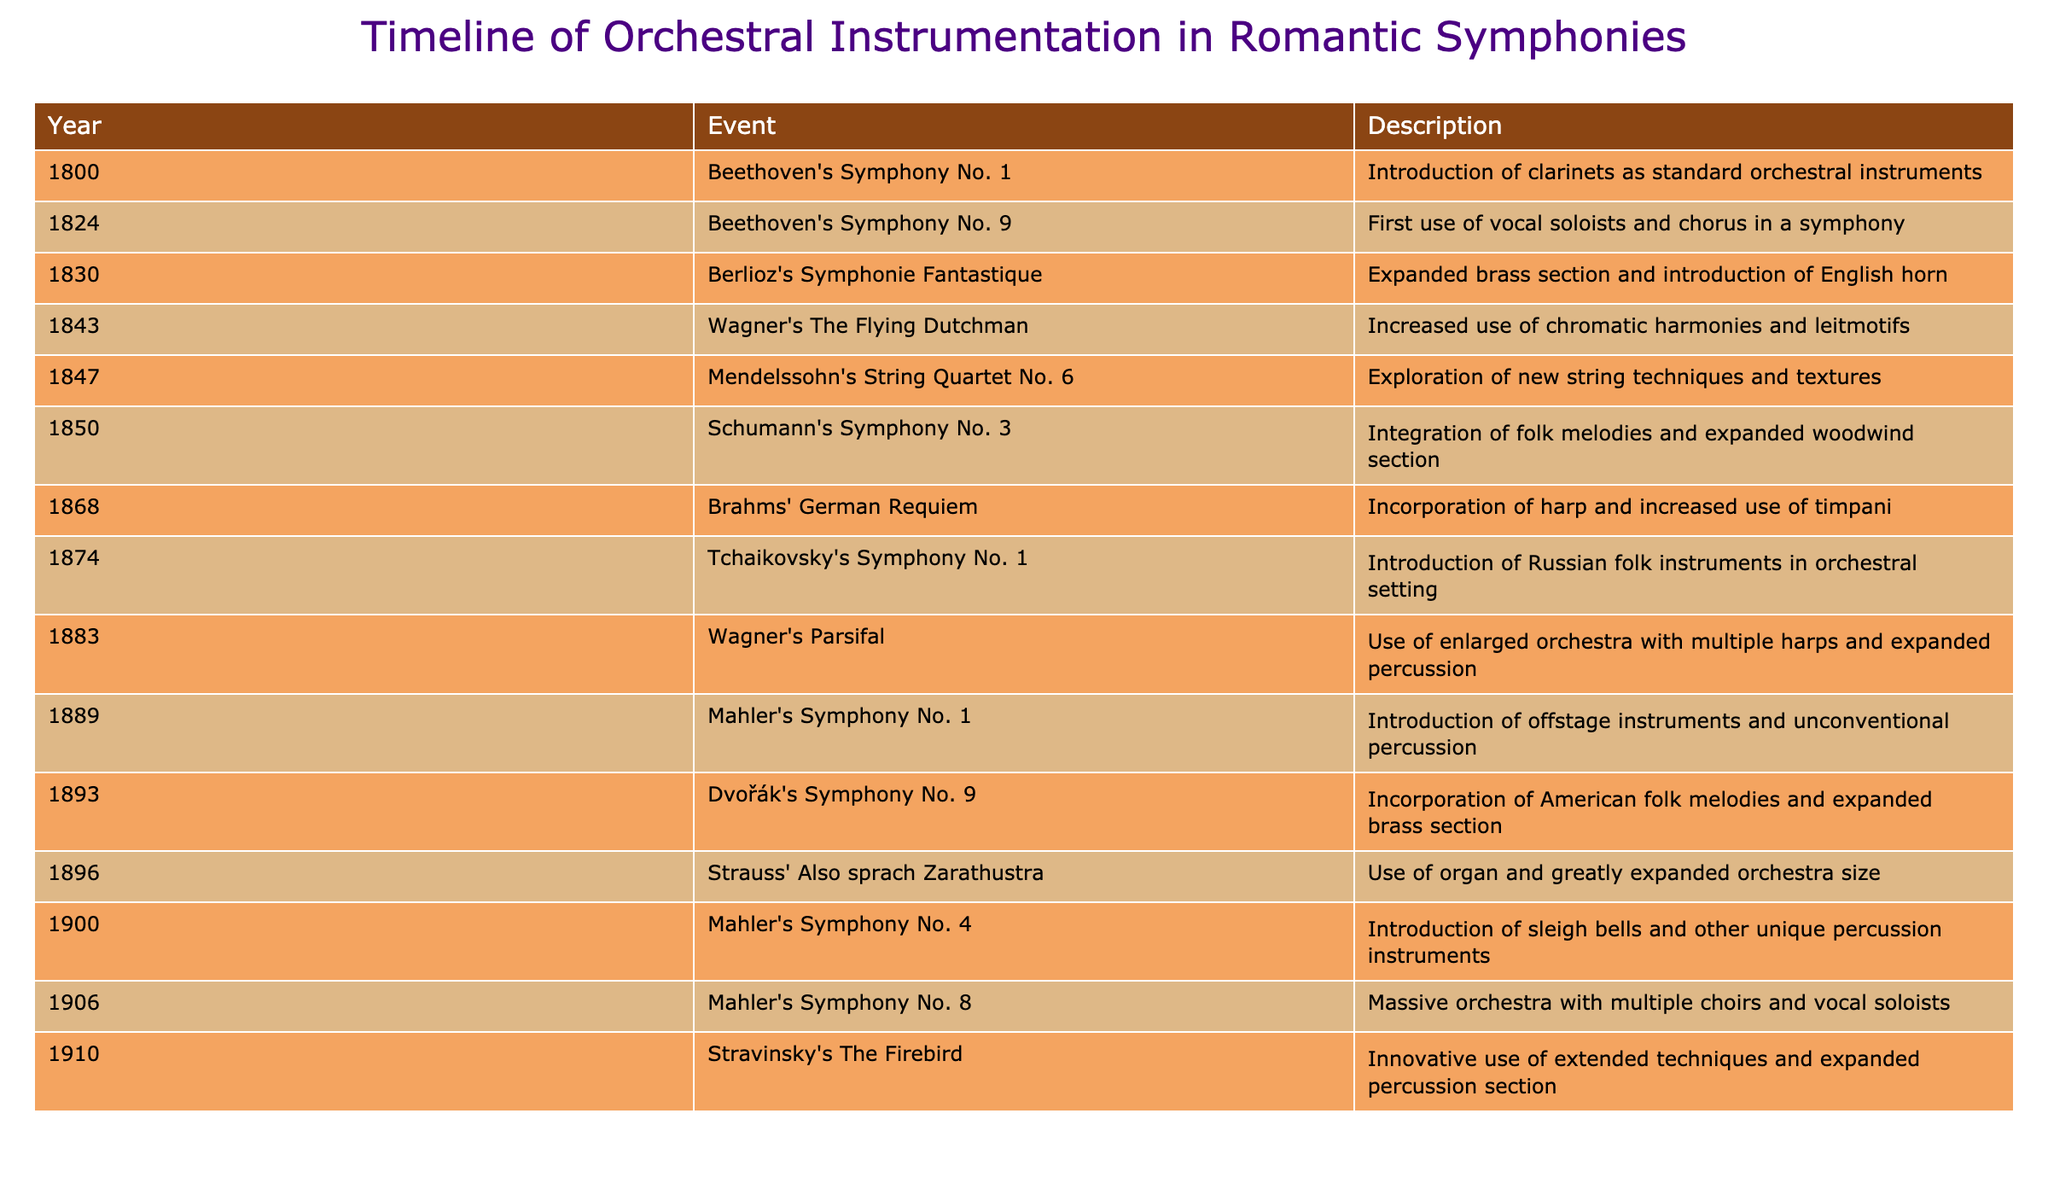What year did Berlioz's "Symphonie Fantastique" premiere? The table lists the year of each event in the related descriptions. For Berlioz's "Symphonie Fantastique," the year given is 1830.
Answer: 1830 Which composer introduced the use of vocal soloists and a chorus in a symphony? The table indicates that Beethoven’s Symphony No. 9, noted for the first use of vocal soloists and chorus in a symphony, was composed in 1824.
Answer: Beethoven In how many years were significant brass instrumentation developments noted? The years with brass instrumentation advancements are 1830 (Berlioz), 1889 (Mahler), and 1893 (Dvořák), totaling three distinct events.
Answer: 3 Did any composer in the timeline incorporate American folk melodies into their symphony? Referring to Dvořák's Symphony No. 9 in 1893, it specifically mentions the incorporation of American folk melodies, which confirms that it did occur.
Answer: Yes Which symphony first used the English horn? The table states that Berlioz's "Symphonie Fantastique" from 1830 included the introduction of the English horn, making it the first noted use.
Answer: Symphonie Fantastique What is the relationship between Wagner and the expansion of orchestral size? The table shows multiple instances involving Wagner; in 1883, Wagner's "Parsifal" used an enlarged orchestra. Therefore, his works are closely associated with the expansion of orchestral size.
Answer: Multiple instances How many symphonies mentioned in the table included the harp? The only symphony that mentions the incorporation of the harp is Brahms' "German Requiem" in 1868. Therefore, only one symphony included this instrument.
Answer: 1 Which year marked the introduction of sleigh bells into orchestral music? The introduction of sleigh bells is noted for Mahler's Symphony No. 4, which premiered in 1900; thus, that is the relevant year.
Answer: 1900 What is the trend regarding the use of woodwind instruments throughout the timeline? If we analyze the data, it shows a consistent trend in the expansion of the woodwind section observed in Schumann's Symphony No. 3 in 1850, indicating a progression in woodwind instrumentation.
Answer: Expansion in use How many years apart were the first and last significant instrumentation milestones mentioned in the timeline? The first milestone is in 1800 (Beethoven's Symphony No. 1) and the last is in 1910 (Stravinsky's The Firebird), which are 110 years apart.
Answer: 110 years 